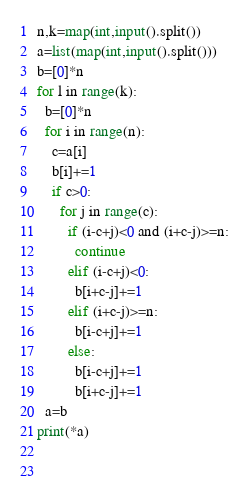<code> <loc_0><loc_0><loc_500><loc_500><_Python_>n,k=map(int,input().split())
a=list(map(int,input().split()))
b=[0]*n
for l in range(k):
  b=[0]*n
  for i in range(n):
    c=a[i]
    b[i]+=1
    if c>0:
      for j in range(c):
        if (i-c+j)<0 and (i+c-j)>=n:
          continue
        elif (i-c+j)<0:
          b[i+c-j]+=1
        elif (i+c-j)>=n:
          b[i-c+j]+=1
        else:
          b[i-c+j]+=1
          b[i+c-j]+=1
  a=b
print(*a)

  </code> 